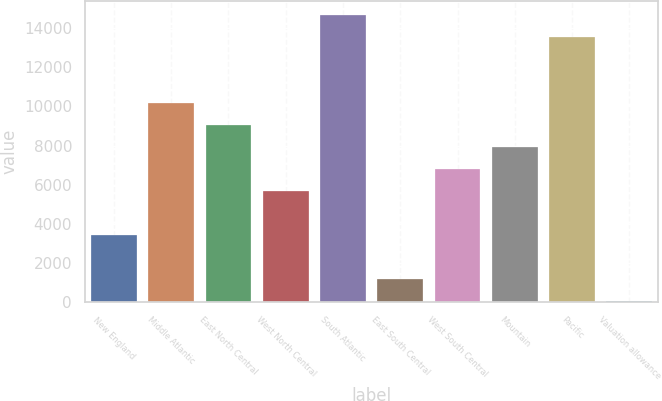Convert chart. <chart><loc_0><loc_0><loc_500><loc_500><bar_chart><fcel>New England<fcel>Middle Atlantic<fcel>East North Central<fcel>West North Central<fcel>South Atlantic<fcel>East South Central<fcel>West South Central<fcel>Mountain<fcel>Pacific<fcel>Valuation allowance<nl><fcel>3423.69<fcel>10157.1<fcel>9034.84<fcel>5668.15<fcel>14646<fcel>1179.23<fcel>6790.38<fcel>7912.61<fcel>13523.8<fcel>57<nl></chart> 